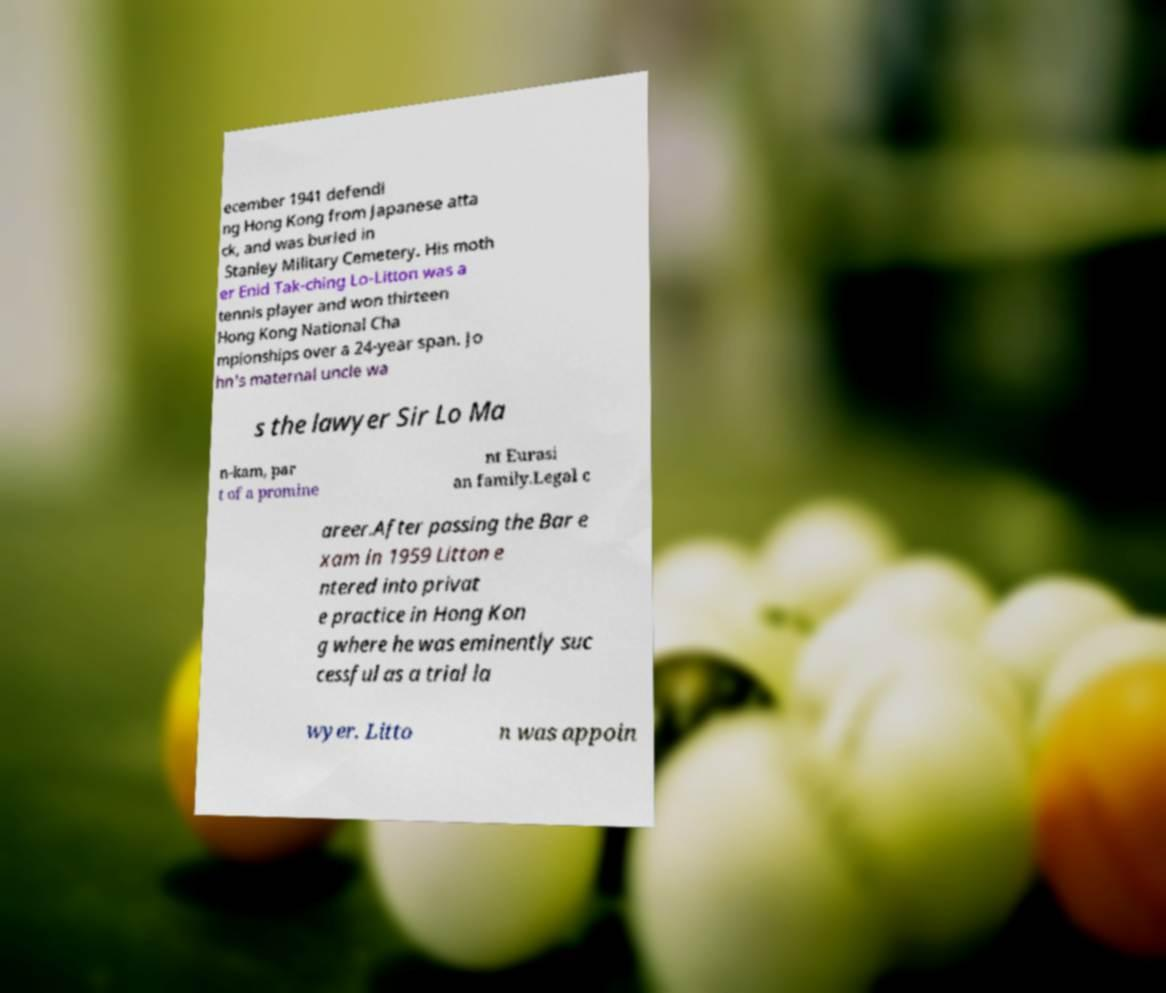Can you accurately transcribe the text from the provided image for me? ecember 1941 defendi ng Hong Kong from Japanese atta ck, and was buried in Stanley Military Cemetery. His moth er Enid Tak-ching Lo-Litton was a tennis player and won thirteen Hong Kong National Cha mpionships over a 24-year span. Jo hn's maternal uncle wa s the lawyer Sir Lo Ma n-kam, par t of a promine nt Eurasi an family.Legal c areer.After passing the Bar e xam in 1959 Litton e ntered into privat e practice in Hong Kon g where he was eminently suc cessful as a trial la wyer. Litto n was appoin 